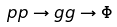Convert formula to latex. <formula><loc_0><loc_0><loc_500><loc_500>p p \to g g \to \Phi</formula> 